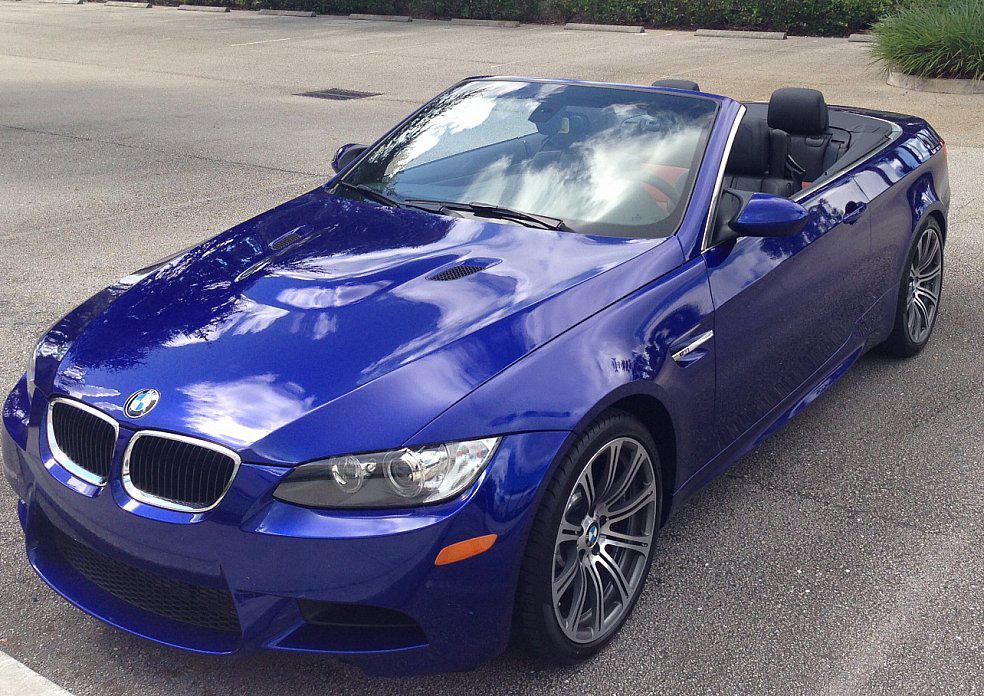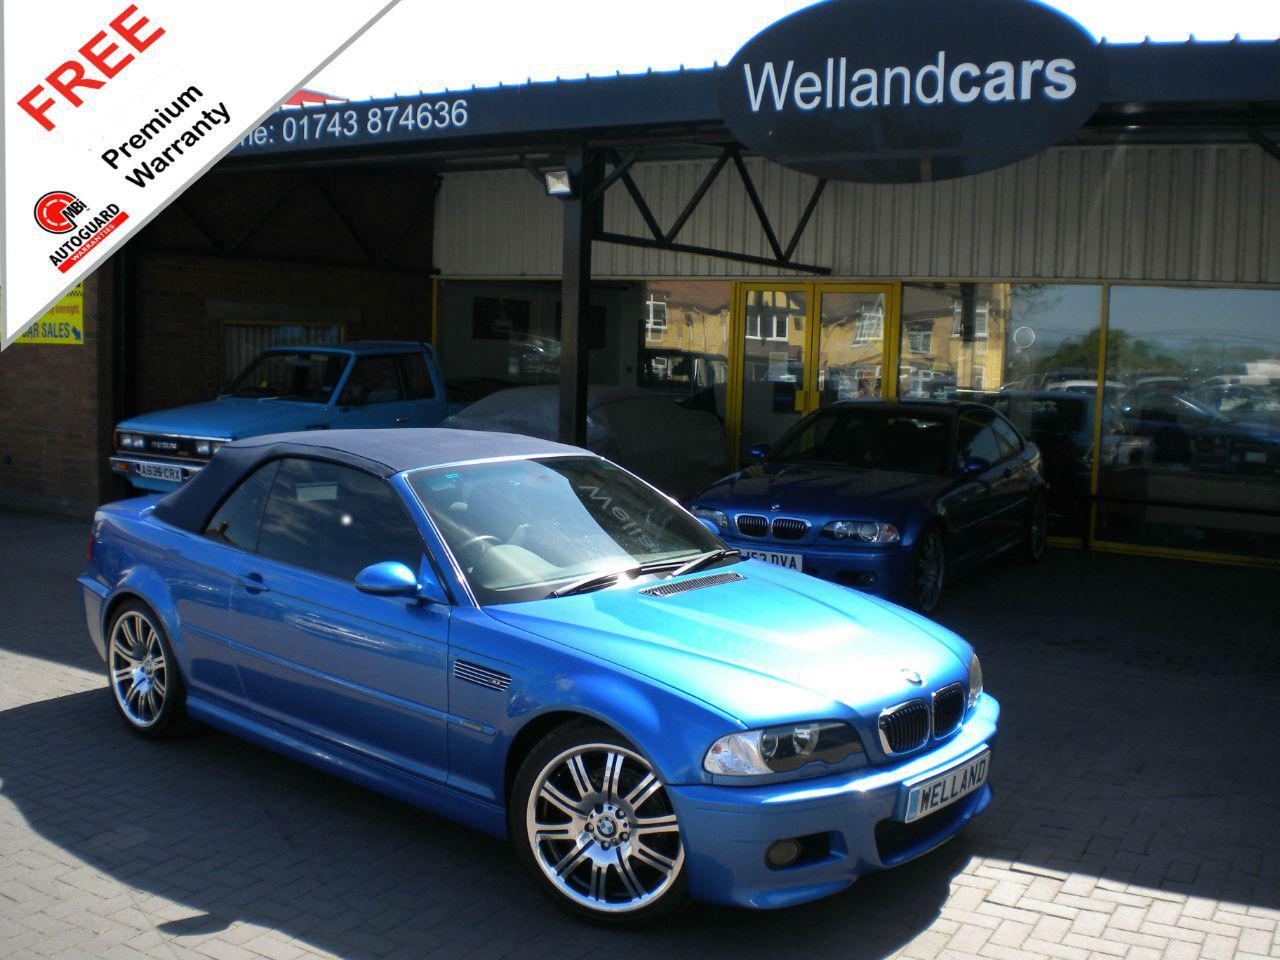The first image is the image on the left, the second image is the image on the right. Examine the images to the left and right. Is the description "In both images the car has it's top down." accurate? Answer yes or no. No. The first image is the image on the left, the second image is the image on the right. Considering the images on both sides, is "The left image contains a royal blue topless convertible displayed at an angle on a gray surface." valid? Answer yes or no. Yes. 